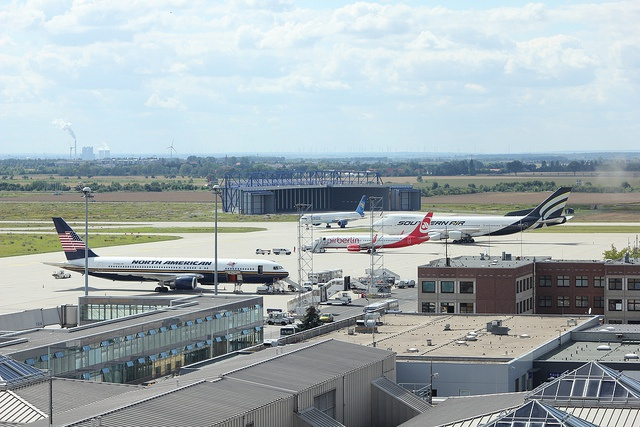Describe the objects in this image and their specific colors. I can see airplane in lightblue, black, white, darkgray, and gray tones, airplane in lightblue, darkgray, lightgray, black, and gray tones, airplane in lightblue, darkgray, lightgray, and brown tones, airplane in lightblue, darkgray, and lightgray tones, and truck in lightblue, gray, darkgray, and black tones in this image. 